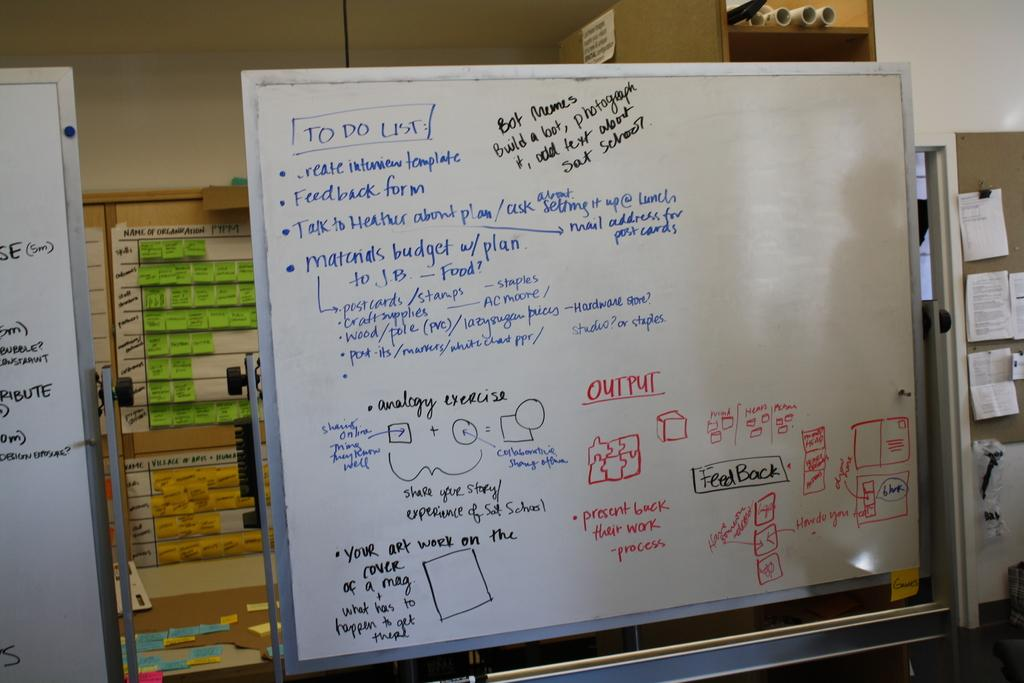<image>
Share a concise interpretation of the image provided. A whiteboard in crowded room that has a To Do List on it along with instructions and small sketches. 